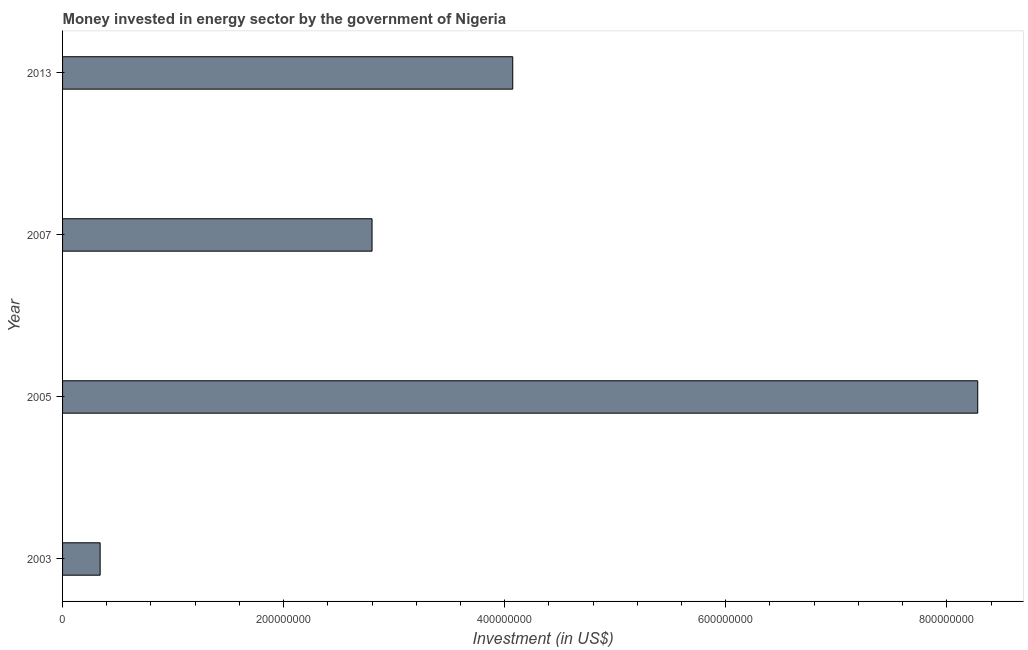Does the graph contain any zero values?
Provide a succinct answer. No. What is the title of the graph?
Make the answer very short. Money invested in energy sector by the government of Nigeria. What is the label or title of the X-axis?
Offer a terse response. Investment (in US$). What is the investment in energy in 2005?
Your answer should be very brief. 8.28e+08. Across all years, what is the maximum investment in energy?
Make the answer very short. 8.28e+08. Across all years, what is the minimum investment in energy?
Your response must be concise. 3.40e+07. In which year was the investment in energy maximum?
Give a very brief answer. 2005. In which year was the investment in energy minimum?
Your answer should be very brief. 2003. What is the sum of the investment in energy?
Your answer should be very brief. 1.55e+09. What is the difference between the investment in energy in 2003 and 2013?
Keep it short and to the point. -3.73e+08. What is the average investment in energy per year?
Give a very brief answer. 3.87e+08. What is the median investment in energy?
Your answer should be compact. 3.44e+08. What is the ratio of the investment in energy in 2003 to that in 2013?
Your answer should be very brief. 0.08. Is the investment in energy in 2005 less than that in 2007?
Offer a very short reply. No. Is the difference between the investment in energy in 2003 and 2007 greater than the difference between any two years?
Make the answer very short. No. What is the difference between the highest and the second highest investment in energy?
Your answer should be compact. 4.21e+08. What is the difference between the highest and the lowest investment in energy?
Make the answer very short. 7.94e+08. Are all the bars in the graph horizontal?
Provide a short and direct response. Yes. How many years are there in the graph?
Give a very brief answer. 4. What is the difference between two consecutive major ticks on the X-axis?
Your answer should be compact. 2.00e+08. What is the Investment (in US$) of 2003?
Offer a terse response. 3.40e+07. What is the Investment (in US$) in 2005?
Your answer should be very brief. 8.28e+08. What is the Investment (in US$) of 2007?
Your answer should be very brief. 2.80e+08. What is the Investment (in US$) of 2013?
Make the answer very short. 4.07e+08. What is the difference between the Investment (in US$) in 2003 and 2005?
Ensure brevity in your answer.  -7.94e+08. What is the difference between the Investment (in US$) in 2003 and 2007?
Keep it short and to the point. -2.46e+08. What is the difference between the Investment (in US$) in 2003 and 2013?
Give a very brief answer. -3.73e+08. What is the difference between the Investment (in US$) in 2005 and 2007?
Provide a short and direct response. 5.48e+08. What is the difference between the Investment (in US$) in 2005 and 2013?
Your response must be concise. 4.21e+08. What is the difference between the Investment (in US$) in 2007 and 2013?
Ensure brevity in your answer.  -1.27e+08. What is the ratio of the Investment (in US$) in 2003 to that in 2005?
Keep it short and to the point. 0.04. What is the ratio of the Investment (in US$) in 2003 to that in 2007?
Make the answer very short. 0.12. What is the ratio of the Investment (in US$) in 2003 to that in 2013?
Your response must be concise. 0.08. What is the ratio of the Investment (in US$) in 2005 to that in 2007?
Ensure brevity in your answer.  2.96. What is the ratio of the Investment (in US$) in 2005 to that in 2013?
Make the answer very short. 2.03. What is the ratio of the Investment (in US$) in 2007 to that in 2013?
Provide a succinct answer. 0.69. 